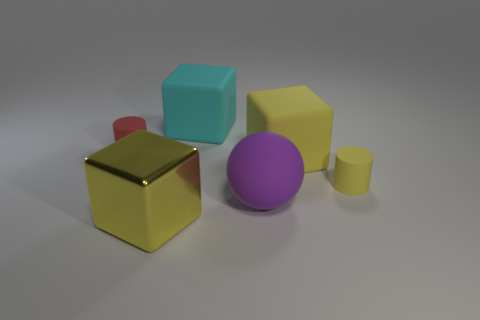What materials do the objects appear to be made from? The objects in the image seem to have surfaces that resemble various materials. The yellow cube looks metallic, possibly gold, given its reflective surface. The red and small yellow objects appear to be made of a matte finish material, possibly plastic. The cyan cube has a similar matte and smooth finish, suggesting a plastic or painted wood material. As for the purple ball, it has a smooth, consistent surface that also suggests a plastic material. 